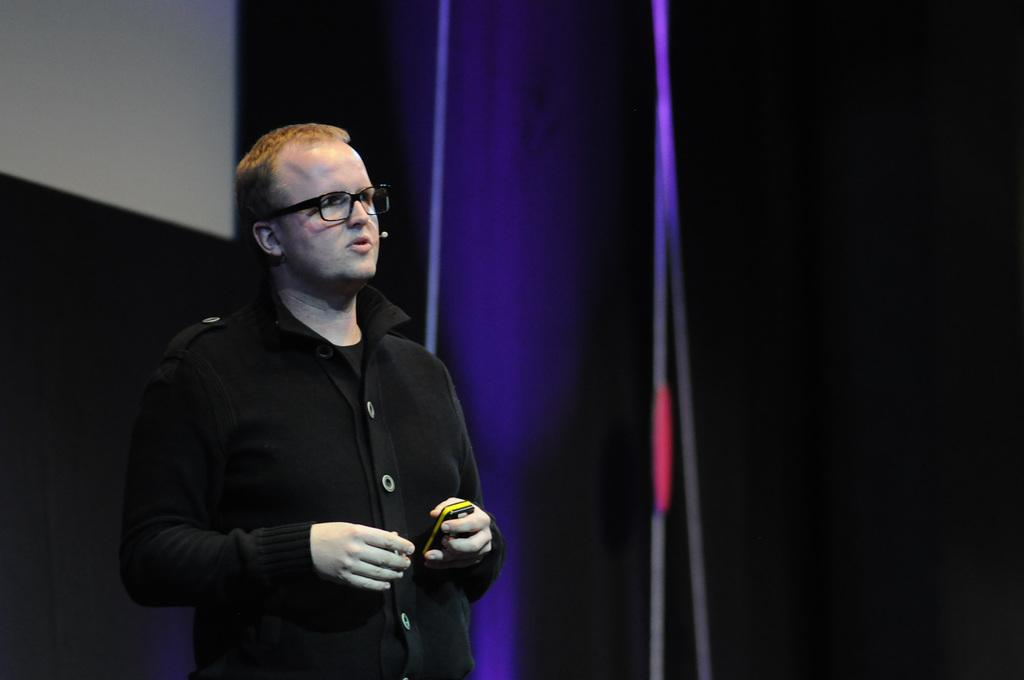What is the main subject of the image? There is a person standing in the image. What is the person holding in the image? The person is holding an object. What can be seen in the background of the image? There are curtains and a wall visible in the background of the image. What type of soda is being poured from the object the person is holding in the image? There is no soda present in the image, nor is there any indication that the person is holding an object related to pouring soda. 